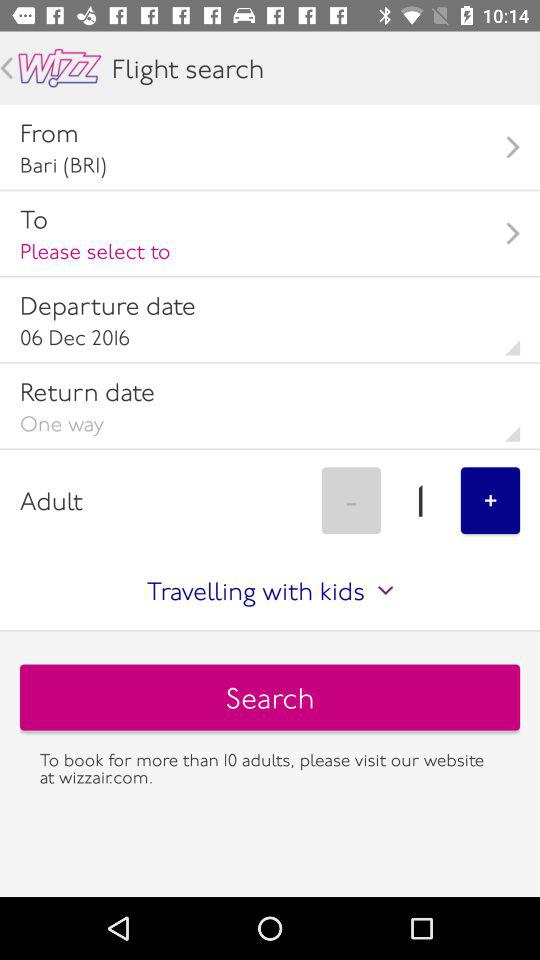How many adults are selected?
Answer the question using a single word or phrase. 1 